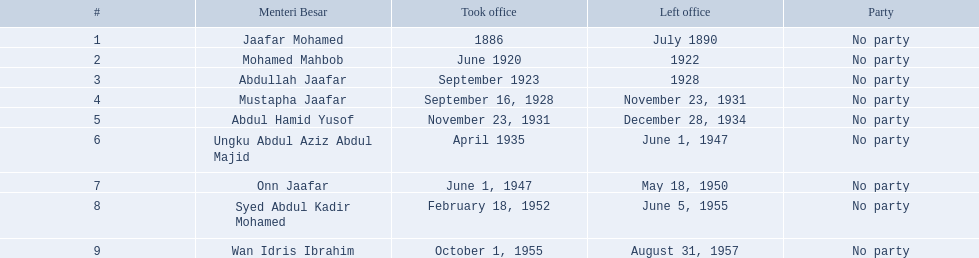What are all the people that were menteri besar of johor? Jaafar Mohamed, Mohamed Mahbob, Abdullah Jaafar, Mustapha Jaafar, Abdul Hamid Yusof, Ungku Abdul Aziz Abdul Majid, Onn Jaafar, Syed Abdul Kadir Mohamed, Wan Idris Ibrahim. Who ruled the longest? Ungku Abdul Aziz Abdul Majid. 